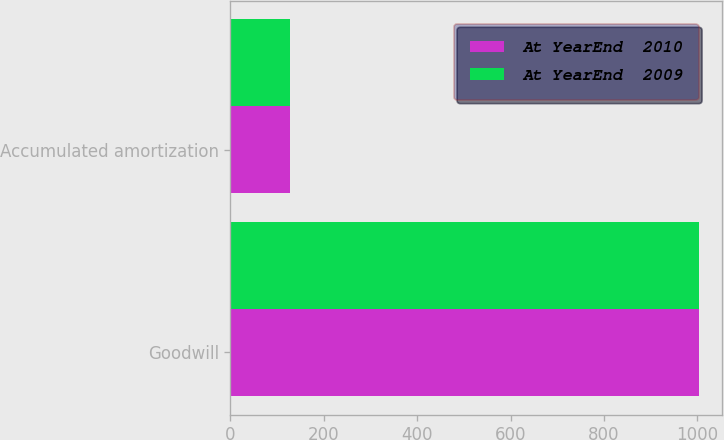Convert chart to OTSL. <chart><loc_0><loc_0><loc_500><loc_500><stacked_bar_chart><ecel><fcel>Goodwill<fcel>Accumulated amortization<nl><fcel>At YearEnd  2010<fcel>1003<fcel>128<nl><fcel>At YearEnd  2009<fcel>1003<fcel>128<nl></chart> 